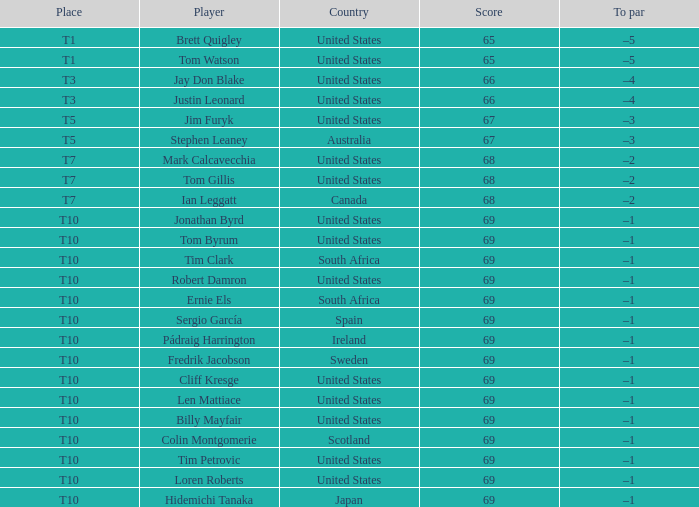In which country is len mattiace ranked in t10 spot? United States. 